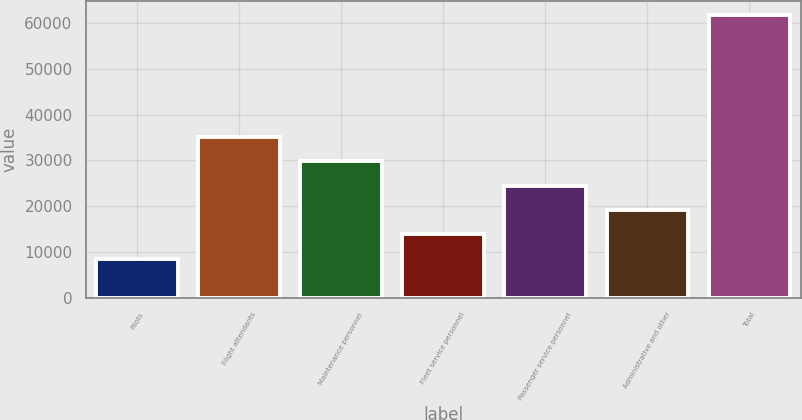<chart> <loc_0><loc_0><loc_500><loc_500><bar_chart><fcel>Pilots<fcel>Flight attendants<fcel>Maintenance personnel<fcel>Fleet service personnel<fcel>Passenger service personnel<fcel>Administrative and other<fcel>Total<nl><fcel>8600<fcel>35100<fcel>29800<fcel>13900<fcel>24500<fcel>19200<fcel>61600<nl></chart> 